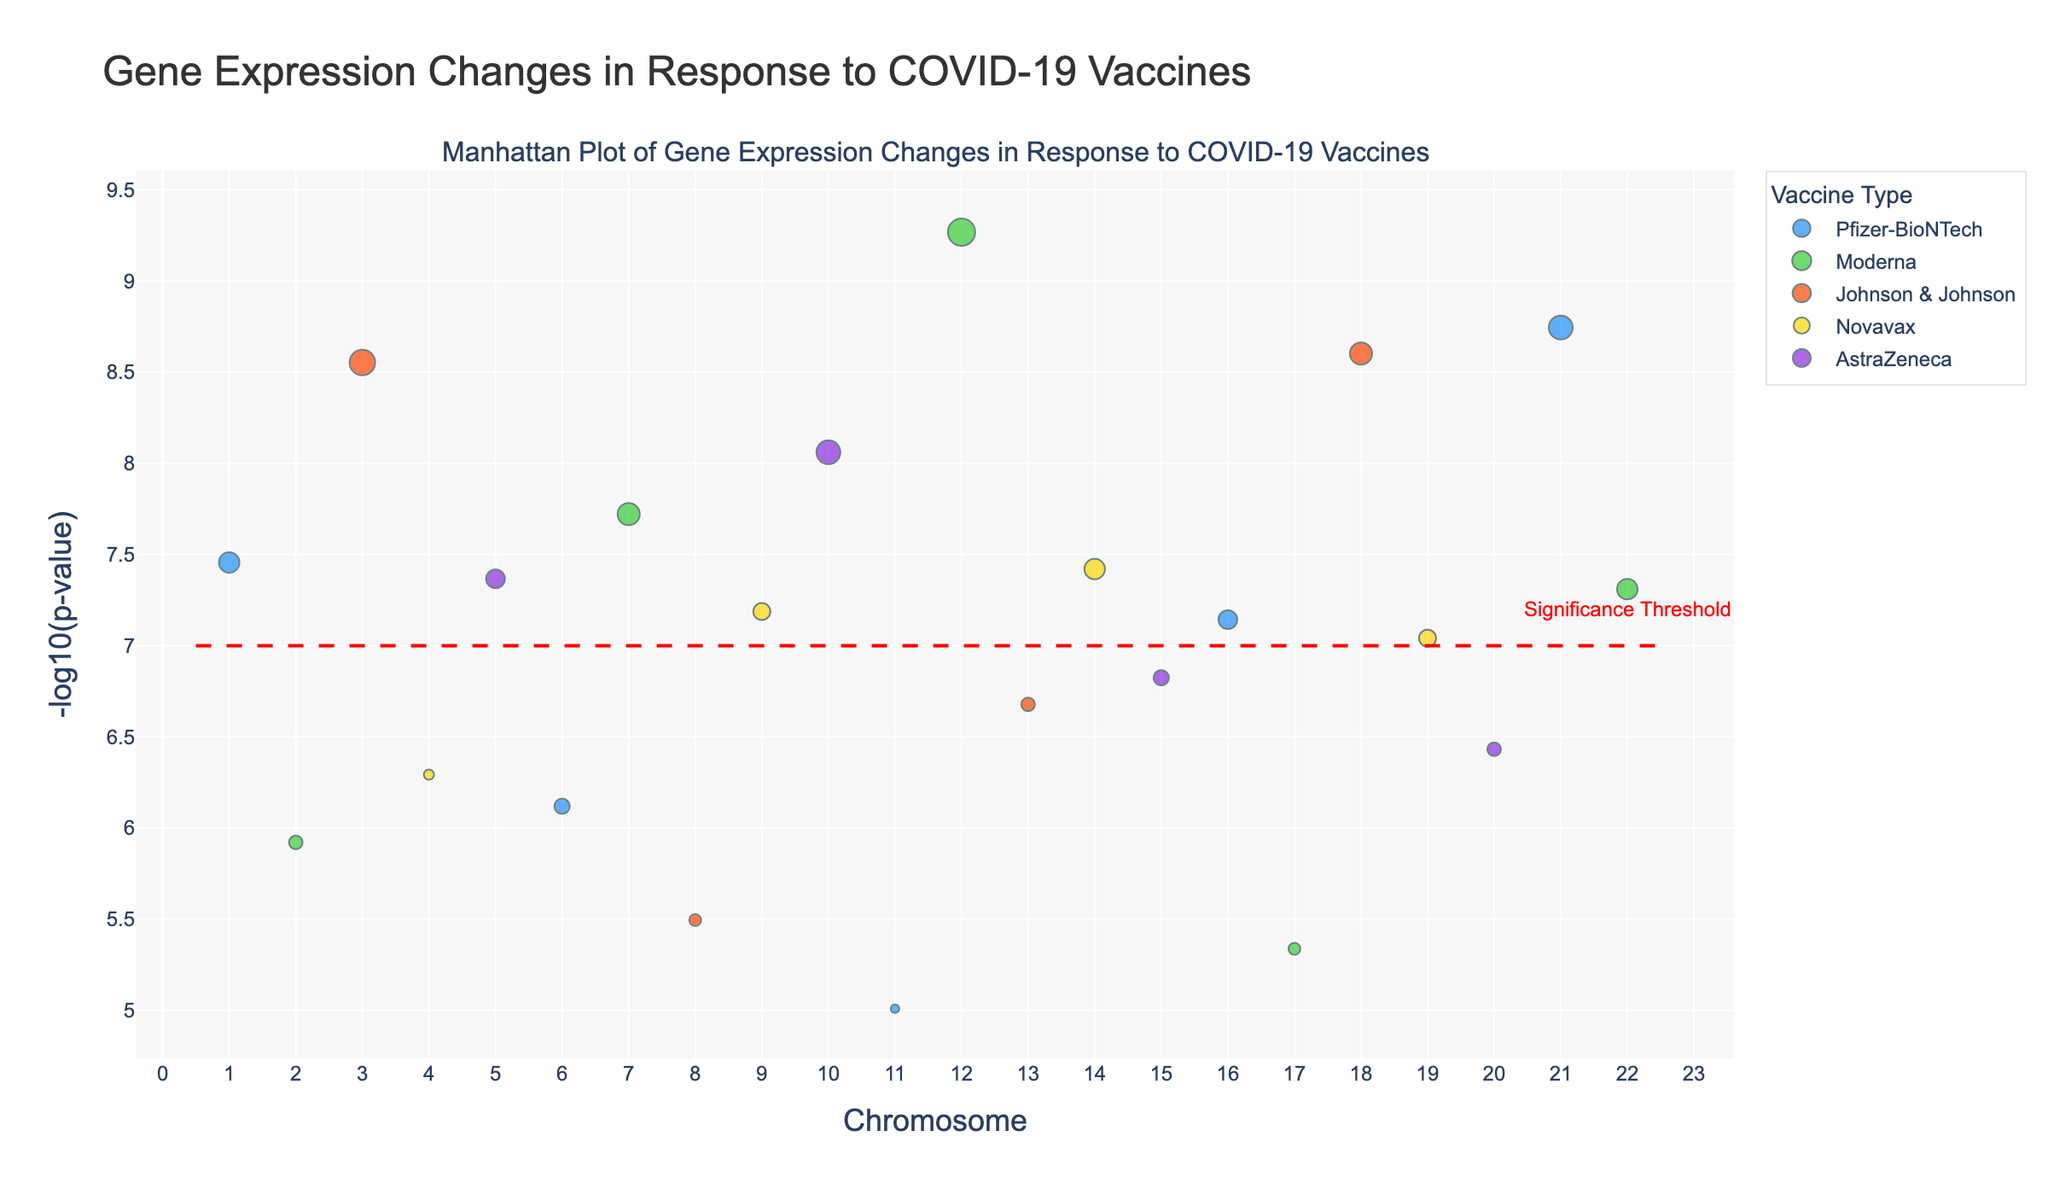What is the title of the plot? The title is displayed prominently at the top of the figure, which reads "Gene Expression Changes in Response to COVID-19 Vaccines."
Answer: Gene Expression Changes in Response to COVID-19 Vaccines Which chromosome has the highest -log10(p-value) and what is its associated gene? By looking at the y-axis for the highest point, you can see that chromosome 12 has the highest -log10(p-value), and the associated gene is CXCL10.
Answer: Chromosome 12, CXCL10 How many distinct vaccine types are represented in the plot? By examining the legend, it can be observed that there are five different colors, each corresponding to a different vaccine type: Pfizer-BioNTech, Moderna, Johnson & Johnson, Novavax, and AstraZeneca.
Answer: 5 Which vaccine type has the most significant gene expression change on chromosome 21? Look at chromosome 21 and see which marker has the highest -log10(p-value). It's evident that Pfizer-BioNTech has the most significant change as it has the highest -log10(p-value) for the gene IFNAR1.
Answer: Pfizer-BioNTech What does the horizontal red dashed line represent? The red dashed line is a common feature in Manhattan Plots marking the significance threshold, above which the changes are considered statistically significant.
Answer: Significance Threshold How many genes have a -log10(p-value) greater than 7? Visual observation of the plot shows that there are four peaks above the red dashed line, indicating four genes with -log10(p-value) greater than 7.
Answer: 4 Which vaccine type is associated with the gene JAK1 and what is its -log10(p-value)? Locate the gene JAK1 from the hover functionality or by its position on chromosome 20, and see the marker color corresponds to AstraZeneca, with a -log10(p-value) of approximately 7.42.
Answer: AstraZeneca, 7.42 Which vaccine type produces the highest logfold change? By examining the size of the markers, it's evident that Moderna, associated with the gene CXCL10, has the highest log fold change of 1.6.
Answer: Moderna How many of the plotted genes have a logfold change greater than 1 for the Pfizer-BioNTech vaccine type? Identify the Pfizer-BioNTech markers (blue) and count the number of larger markers. There are three: ACE2, HLA-A, and IFNAR1.
Answer: 3 Compare the significance of the TNF gene for Novavax and the STAT1 gene for Novavax. Which gene is more significant? Compare the y-values (-log10(p-value)) of the TNF gene on chromosome 4 and the STAT1 gene on chromosome 19. The TNF gene has a y-value around 6.29, while STAT1 has a higher value at about 7.04, making STAT1 more significant.
Answer: STAT1 